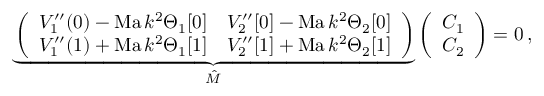<formula> <loc_0><loc_0><loc_500><loc_500>\underbrace { \left ( \begin{array} { l l } { V _ { 1 } ^ { \prime \prime } ( 0 ) - M a \, k ^ { 2 } \Theta _ { 1 } [ 0 ] } & { V _ { 2 } ^ { \prime \prime } [ 0 ] - M a \, k ^ { 2 } \Theta _ { 2 } [ 0 ] } \\ { V _ { 1 } ^ { \prime \prime } ( 1 ) + M a \, k ^ { 2 } \Theta _ { 1 } [ 1 ] } & { V _ { 2 } ^ { \prime \prime } [ 1 ] + M a \, k ^ { 2 } \Theta _ { 2 } [ 1 ] } \end{array} \right ) } _ { \hat { M } } \left ( \begin{array} { l } { C _ { 1 } } \\ { C _ { 2 } } \end{array} \right ) = 0 \, ,</formula> 